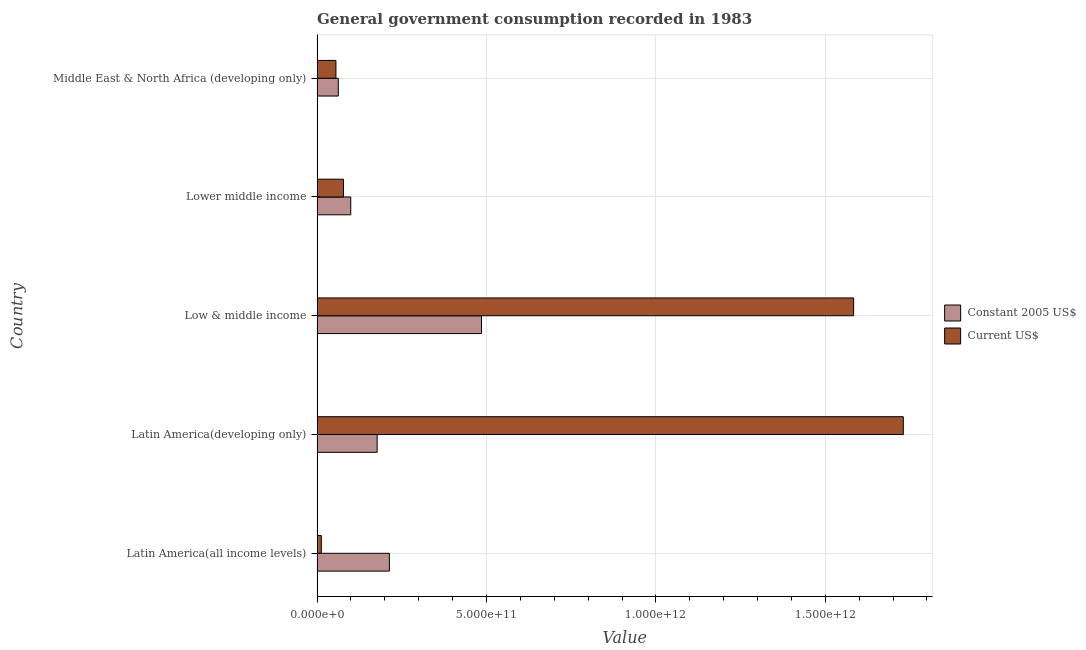How many different coloured bars are there?
Offer a very short reply. 2. Are the number of bars on each tick of the Y-axis equal?
Your answer should be very brief. Yes. What is the label of the 5th group of bars from the top?
Keep it short and to the point. Latin America(all income levels). What is the value consumed in constant 2005 us$ in Lower middle income?
Offer a terse response. 9.95e+1. Across all countries, what is the maximum value consumed in constant 2005 us$?
Give a very brief answer. 4.85e+11. Across all countries, what is the minimum value consumed in current us$?
Give a very brief answer. 1.26e+1. In which country was the value consumed in current us$ maximum?
Your answer should be very brief. Latin America(developing only). In which country was the value consumed in current us$ minimum?
Give a very brief answer. Latin America(all income levels). What is the total value consumed in current us$ in the graph?
Offer a terse response. 3.46e+12. What is the difference between the value consumed in constant 2005 us$ in Latin America(all income levels) and that in Low & middle income?
Provide a short and direct response. -2.72e+11. What is the difference between the value consumed in current us$ in Low & middle income and the value consumed in constant 2005 us$ in Latin America(all income levels)?
Your answer should be compact. 1.37e+12. What is the average value consumed in constant 2005 us$ per country?
Provide a succinct answer. 2.08e+11. What is the difference between the value consumed in constant 2005 us$ and value consumed in current us$ in Lower middle income?
Offer a very short reply. 2.16e+1. What is the ratio of the value consumed in current us$ in Latin America(all income levels) to that in Low & middle income?
Make the answer very short. 0.01. Is the value consumed in constant 2005 us$ in Latin America(developing only) less than that in Low & middle income?
Offer a very short reply. Yes. What is the difference between the highest and the second highest value consumed in current us$?
Offer a terse response. 1.47e+11. What is the difference between the highest and the lowest value consumed in current us$?
Your answer should be very brief. 1.72e+12. In how many countries, is the value consumed in current us$ greater than the average value consumed in current us$ taken over all countries?
Keep it short and to the point. 2. What does the 1st bar from the top in Latin America(all income levels) represents?
Give a very brief answer. Current US$. What does the 1st bar from the bottom in Lower middle income represents?
Your response must be concise. Constant 2005 US$. How many bars are there?
Provide a succinct answer. 10. What is the difference between two consecutive major ticks on the X-axis?
Offer a very short reply. 5.00e+11. Are the values on the major ticks of X-axis written in scientific E-notation?
Your answer should be compact. Yes. Does the graph contain any zero values?
Make the answer very short. No. How are the legend labels stacked?
Ensure brevity in your answer.  Vertical. What is the title of the graph?
Provide a succinct answer. General government consumption recorded in 1983. Does "Travel Items" appear as one of the legend labels in the graph?
Your answer should be very brief. No. What is the label or title of the X-axis?
Offer a terse response. Value. What is the Value of Constant 2005 US$ in Latin America(all income levels)?
Make the answer very short. 2.13e+11. What is the Value in Current US$ in Latin America(all income levels)?
Your response must be concise. 1.26e+1. What is the Value of Constant 2005 US$ in Latin America(developing only)?
Your answer should be very brief. 1.77e+11. What is the Value in Current US$ in Latin America(developing only)?
Give a very brief answer. 1.73e+12. What is the Value in Constant 2005 US$ in Low & middle income?
Your response must be concise. 4.85e+11. What is the Value of Current US$ in Low & middle income?
Give a very brief answer. 1.58e+12. What is the Value in Constant 2005 US$ in Lower middle income?
Provide a short and direct response. 9.95e+1. What is the Value of Current US$ in Lower middle income?
Your response must be concise. 7.79e+1. What is the Value in Constant 2005 US$ in Middle East & North Africa (developing only)?
Your answer should be very brief. 6.27e+1. What is the Value of Current US$ in Middle East & North Africa (developing only)?
Make the answer very short. 5.57e+1. Across all countries, what is the maximum Value of Constant 2005 US$?
Your response must be concise. 4.85e+11. Across all countries, what is the maximum Value in Current US$?
Offer a very short reply. 1.73e+12. Across all countries, what is the minimum Value in Constant 2005 US$?
Provide a succinct answer. 6.27e+1. Across all countries, what is the minimum Value of Current US$?
Ensure brevity in your answer.  1.26e+1. What is the total Value in Constant 2005 US$ in the graph?
Provide a short and direct response. 1.04e+12. What is the total Value of Current US$ in the graph?
Offer a very short reply. 3.46e+12. What is the difference between the Value in Constant 2005 US$ in Latin America(all income levels) and that in Latin America(developing only)?
Make the answer very short. 3.61e+1. What is the difference between the Value in Current US$ in Latin America(all income levels) and that in Latin America(developing only)?
Offer a very short reply. -1.72e+12. What is the difference between the Value of Constant 2005 US$ in Latin America(all income levels) and that in Low & middle income?
Offer a terse response. -2.72e+11. What is the difference between the Value in Current US$ in Latin America(all income levels) and that in Low & middle income?
Keep it short and to the point. -1.57e+12. What is the difference between the Value in Constant 2005 US$ in Latin America(all income levels) and that in Lower middle income?
Offer a very short reply. 1.14e+11. What is the difference between the Value in Current US$ in Latin America(all income levels) and that in Lower middle income?
Give a very brief answer. -6.53e+1. What is the difference between the Value in Constant 2005 US$ in Latin America(all income levels) and that in Middle East & North Africa (developing only)?
Offer a very short reply. 1.51e+11. What is the difference between the Value of Current US$ in Latin America(all income levels) and that in Middle East & North Africa (developing only)?
Your answer should be compact. -4.31e+1. What is the difference between the Value of Constant 2005 US$ in Latin America(developing only) and that in Low & middle income?
Offer a very short reply. -3.08e+11. What is the difference between the Value in Current US$ in Latin America(developing only) and that in Low & middle income?
Give a very brief answer. 1.47e+11. What is the difference between the Value in Constant 2005 US$ in Latin America(developing only) and that in Lower middle income?
Your answer should be compact. 7.79e+1. What is the difference between the Value of Current US$ in Latin America(developing only) and that in Lower middle income?
Your response must be concise. 1.65e+12. What is the difference between the Value in Constant 2005 US$ in Latin America(developing only) and that in Middle East & North Africa (developing only)?
Your response must be concise. 1.15e+11. What is the difference between the Value in Current US$ in Latin America(developing only) and that in Middle East & North Africa (developing only)?
Offer a terse response. 1.67e+12. What is the difference between the Value of Constant 2005 US$ in Low & middle income and that in Lower middle income?
Ensure brevity in your answer.  3.86e+11. What is the difference between the Value of Current US$ in Low & middle income and that in Lower middle income?
Keep it short and to the point. 1.51e+12. What is the difference between the Value of Constant 2005 US$ in Low & middle income and that in Middle East & North Africa (developing only)?
Ensure brevity in your answer.  4.23e+11. What is the difference between the Value of Current US$ in Low & middle income and that in Middle East & North Africa (developing only)?
Provide a short and direct response. 1.53e+12. What is the difference between the Value in Constant 2005 US$ in Lower middle income and that in Middle East & North Africa (developing only)?
Provide a succinct answer. 3.68e+1. What is the difference between the Value of Current US$ in Lower middle income and that in Middle East & North Africa (developing only)?
Keep it short and to the point. 2.22e+1. What is the difference between the Value in Constant 2005 US$ in Latin America(all income levels) and the Value in Current US$ in Latin America(developing only)?
Provide a succinct answer. -1.52e+12. What is the difference between the Value of Constant 2005 US$ in Latin America(all income levels) and the Value of Current US$ in Low & middle income?
Ensure brevity in your answer.  -1.37e+12. What is the difference between the Value in Constant 2005 US$ in Latin America(all income levels) and the Value in Current US$ in Lower middle income?
Ensure brevity in your answer.  1.36e+11. What is the difference between the Value in Constant 2005 US$ in Latin America(all income levels) and the Value in Current US$ in Middle East & North Africa (developing only)?
Offer a very short reply. 1.58e+11. What is the difference between the Value in Constant 2005 US$ in Latin America(developing only) and the Value in Current US$ in Low & middle income?
Provide a succinct answer. -1.41e+12. What is the difference between the Value of Constant 2005 US$ in Latin America(developing only) and the Value of Current US$ in Lower middle income?
Offer a very short reply. 9.94e+1. What is the difference between the Value of Constant 2005 US$ in Latin America(developing only) and the Value of Current US$ in Middle East & North Africa (developing only)?
Provide a short and direct response. 1.22e+11. What is the difference between the Value of Constant 2005 US$ in Low & middle income and the Value of Current US$ in Lower middle income?
Provide a short and direct response. 4.08e+11. What is the difference between the Value in Constant 2005 US$ in Low & middle income and the Value in Current US$ in Middle East & North Africa (developing only)?
Your answer should be very brief. 4.30e+11. What is the difference between the Value of Constant 2005 US$ in Lower middle income and the Value of Current US$ in Middle East & North Africa (developing only)?
Keep it short and to the point. 4.38e+1. What is the average Value of Constant 2005 US$ per country?
Provide a succinct answer. 2.08e+11. What is the average Value in Current US$ per country?
Make the answer very short. 6.92e+11. What is the difference between the Value in Constant 2005 US$ and Value in Current US$ in Latin America(all income levels)?
Your answer should be compact. 2.01e+11. What is the difference between the Value in Constant 2005 US$ and Value in Current US$ in Latin America(developing only)?
Offer a very short reply. -1.55e+12. What is the difference between the Value of Constant 2005 US$ and Value of Current US$ in Low & middle income?
Offer a terse response. -1.10e+12. What is the difference between the Value of Constant 2005 US$ and Value of Current US$ in Lower middle income?
Your answer should be very brief. 2.16e+1. What is the difference between the Value of Constant 2005 US$ and Value of Current US$ in Middle East & North Africa (developing only)?
Ensure brevity in your answer.  6.99e+09. What is the ratio of the Value of Constant 2005 US$ in Latin America(all income levels) to that in Latin America(developing only)?
Make the answer very short. 1.2. What is the ratio of the Value in Current US$ in Latin America(all income levels) to that in Latin America(developing only)?
Give a very brief answer. 0.01. What is the ratio of the Value of Constant 2005 US$ in Latin America(all income levels) to that in Low & middle income?
Offer a terse response. 0.44. What is the ratio of the Value of Current US$ in Latin America(all income levels) to that in Low & middle income?
Your answer should be very brief. 0.01. What is the ratio of the Value in Constant 2005 US$ in Latin America(all income levels) to that in Lower middle income?
Give a very brief answer. 2.15. What is the ratio of the Value of Current US$ in Latin America(all income levels) to that in Lower middle income?
Provide a succinct answer. 0.16. What is the ratio of the Value of Constant 2005 US$ in Latin America(all income levels) to that in Middle East & North Africa (developing only)?
Offer a very short reply. 3.4. What is the ratio of the Value of Current US$ in Latin America(all income levels) to that in Middle East & North Africa (developing only)?
Offer a terse response. 0.23. What is the ratio of the Value in Constant 2005 US$ in Latin America(developing only) to that in Low & middle income?
Provide a succinct answer. 0.37. What is the ratio of the Value in Current US$ in Latin America(developing only) to that in Low & middle income?
Provide a short and direct response. 1.09. What is the ratio of the Value in Constant 2005 US$ in Latin America(developing only) to that in Lower middle income?
Keep it short and to the point. 1.78. What is the ratio of the Value of Current US$ in Latin America(developing only) to that in Lower middle income?
Provide a succinct answer. 22.21. What is the ratio of the Value in Constant 2005 US$ in Latin America(developing only) to that in Middle East & North Africa (developing only)?
Offer a terse response. 2.83. What is the ratio of the Value in Current US$ in Latin America(developing only) to that in Middle East & North Africa (developing only)?
Provide a short and direct response. 31.07. What is the ratio of the Value of Constant 2005 US$ in Low & middle income to that in Lower middle income?
Make the answer very short. 4.88. What is the ratio of the Value of Current US$ in Low & middle income to that in Lower middle income?
Offer a very short reply. 20.33. What is the ratio of the Value in Constant 2005 US$ in Low & middle income to that in Middle East & North Africa (developing only)?
Give a very brief answer. 7.74. What is the ratio of the Value in Current US$ in Low & middle income to that in Middle East & North Africa (developing only)?
Ensure brevity in your answer.  28.43. What is the ratio of the Value of Constant 2005 US$ in Lower middle income to that in Middle East & North Africa (developing only)?
Offer a terse response. 1.59. What is the ratio of the Value of Current US$ in Lower middle income to that in Middle East & North Africa (developing only)?
Offer a terse response. 1.4. What is the difference between the highest and the second highest Value of Constant 2005 US$?
Give a very brief answer. 2.72e+11. What is the difference between the highest and the second highest Value of Current US$?
Your answer should be compact. 1.47e+11. What is the difference between the highest and the lowest Value of Constant 2005 US$?
Provide a short and direct response. 4.23e+11. What is the difference between the highest and the lowest Value of Current US$?
Provide a succinct answer. 1.72e+12. 